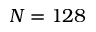<formula> <loc_0><loc_0><loc_500><loc_500>N = 1 2 8</formula> 